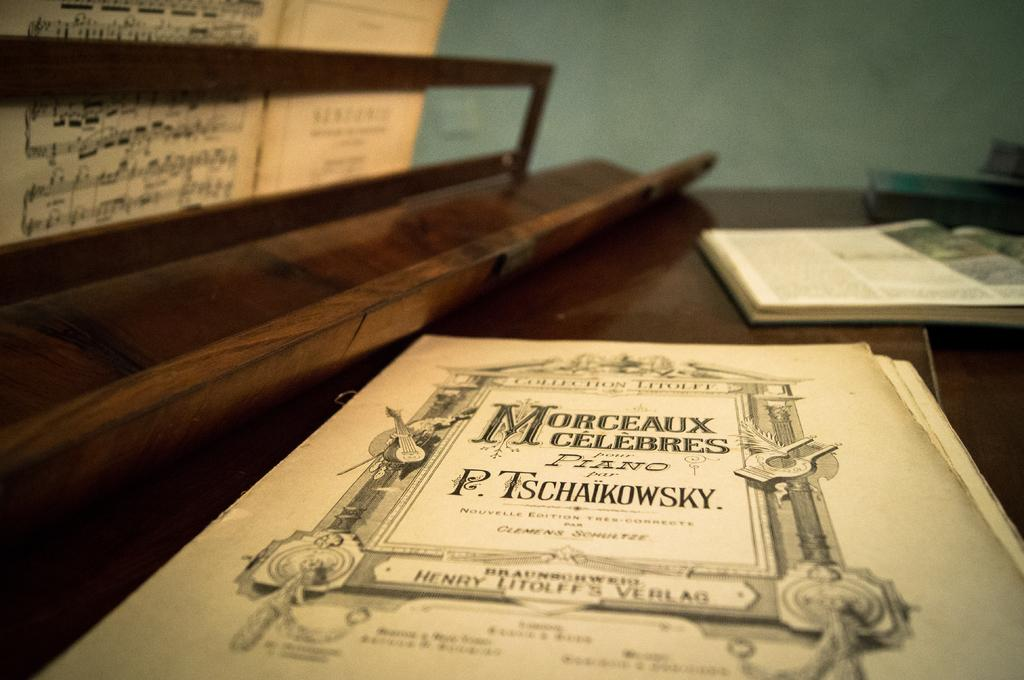<image>
Give a short and clear explanation of the subsequent image. Piano books on a wooden surface perhaps a piano including Morceaux Celebres. 